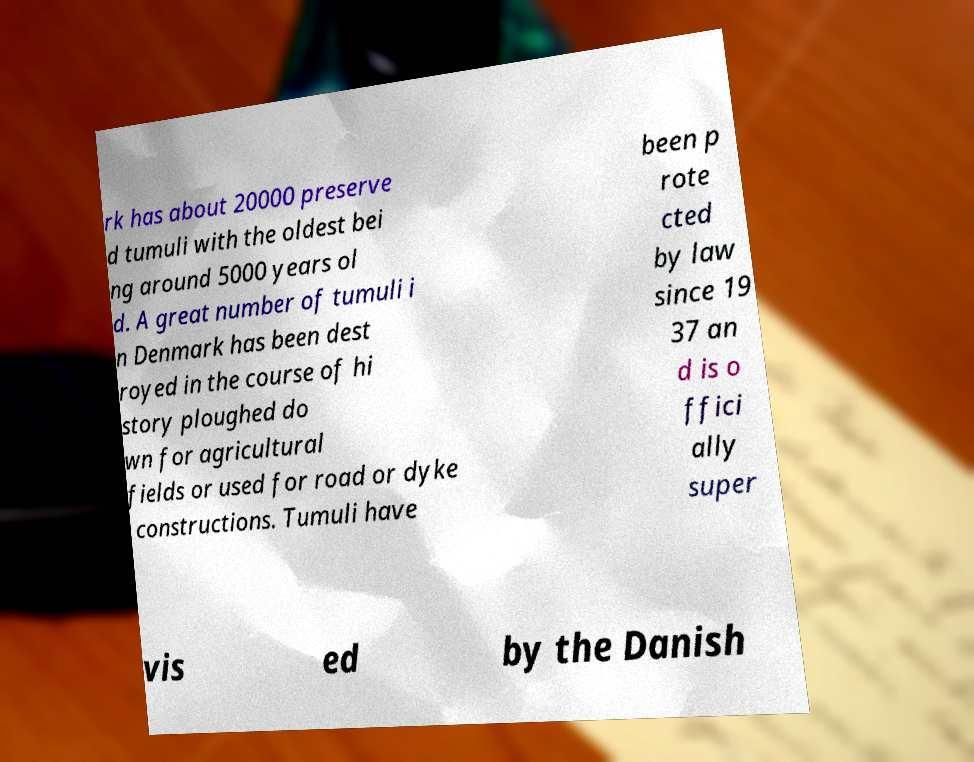I need the written content from this picture converted into text. Can you do that? rk has about 20000 preserve d tumuli with the oldest bei ng around 5000 years ol d. A great number of tumuli i n Denmark has been dest royed in the course of hi story ploughed do wn for agricultural fields or used for road or dyke constructions. Tumuli have been p rote cted by law since 19 37 an d is o ffici ally super vis ed by the Danish 